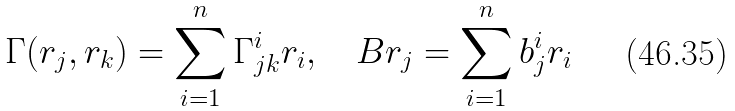<formula> <loc_0><loc_0><loc_500><loc_500>\Gamma ( r _ { j } , r _ { k } ) = \sum _ { i = 1 } ^ { n } \Gamma _ { j k } ^ { i } r _ { i } , \quad B r _ { j } = \sum _ { i = 1 } ^ { n } b ^ { i } _ { j } r _ { i }</formula> 